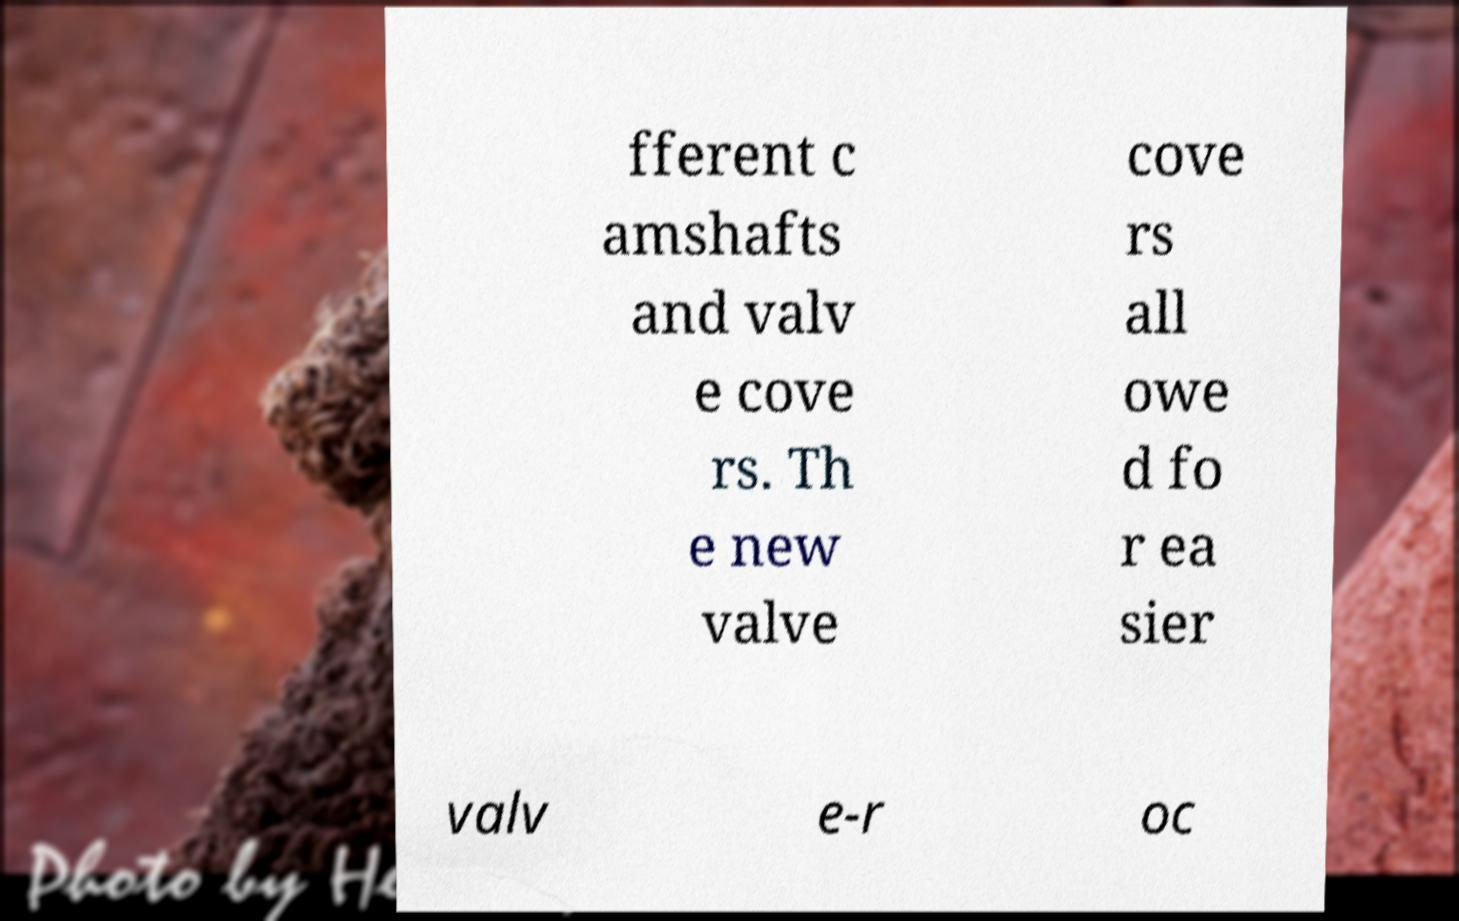I need the written content from this picture converted into text. Can you do that? fferent c amshafts and valv e cove rs. Th e new valve cove rs all owe d fo r ea sier valv e-r oc 